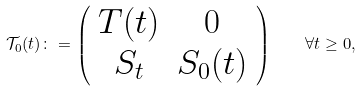Convert formula to latex. <formula><loc_0><loc_0><loc_500><loc_500>\mathcal { T } _ { 0 } ( t ) \colon = \left ( \begin{array} { c c } T ( t ) & 0 \\ S _ { t } & S _ { 0 } ( t ) \end{array} \right ) \quad \forall t \geq 0 ,</formula> 